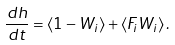<formula> <loc_0><loc_0><loc_500><loc_500>\frac { d h } { d t } = \langle 1 - W _ { i } \rangle + \langle F _ { i } W _ { i } \rangle \, .</formula> 